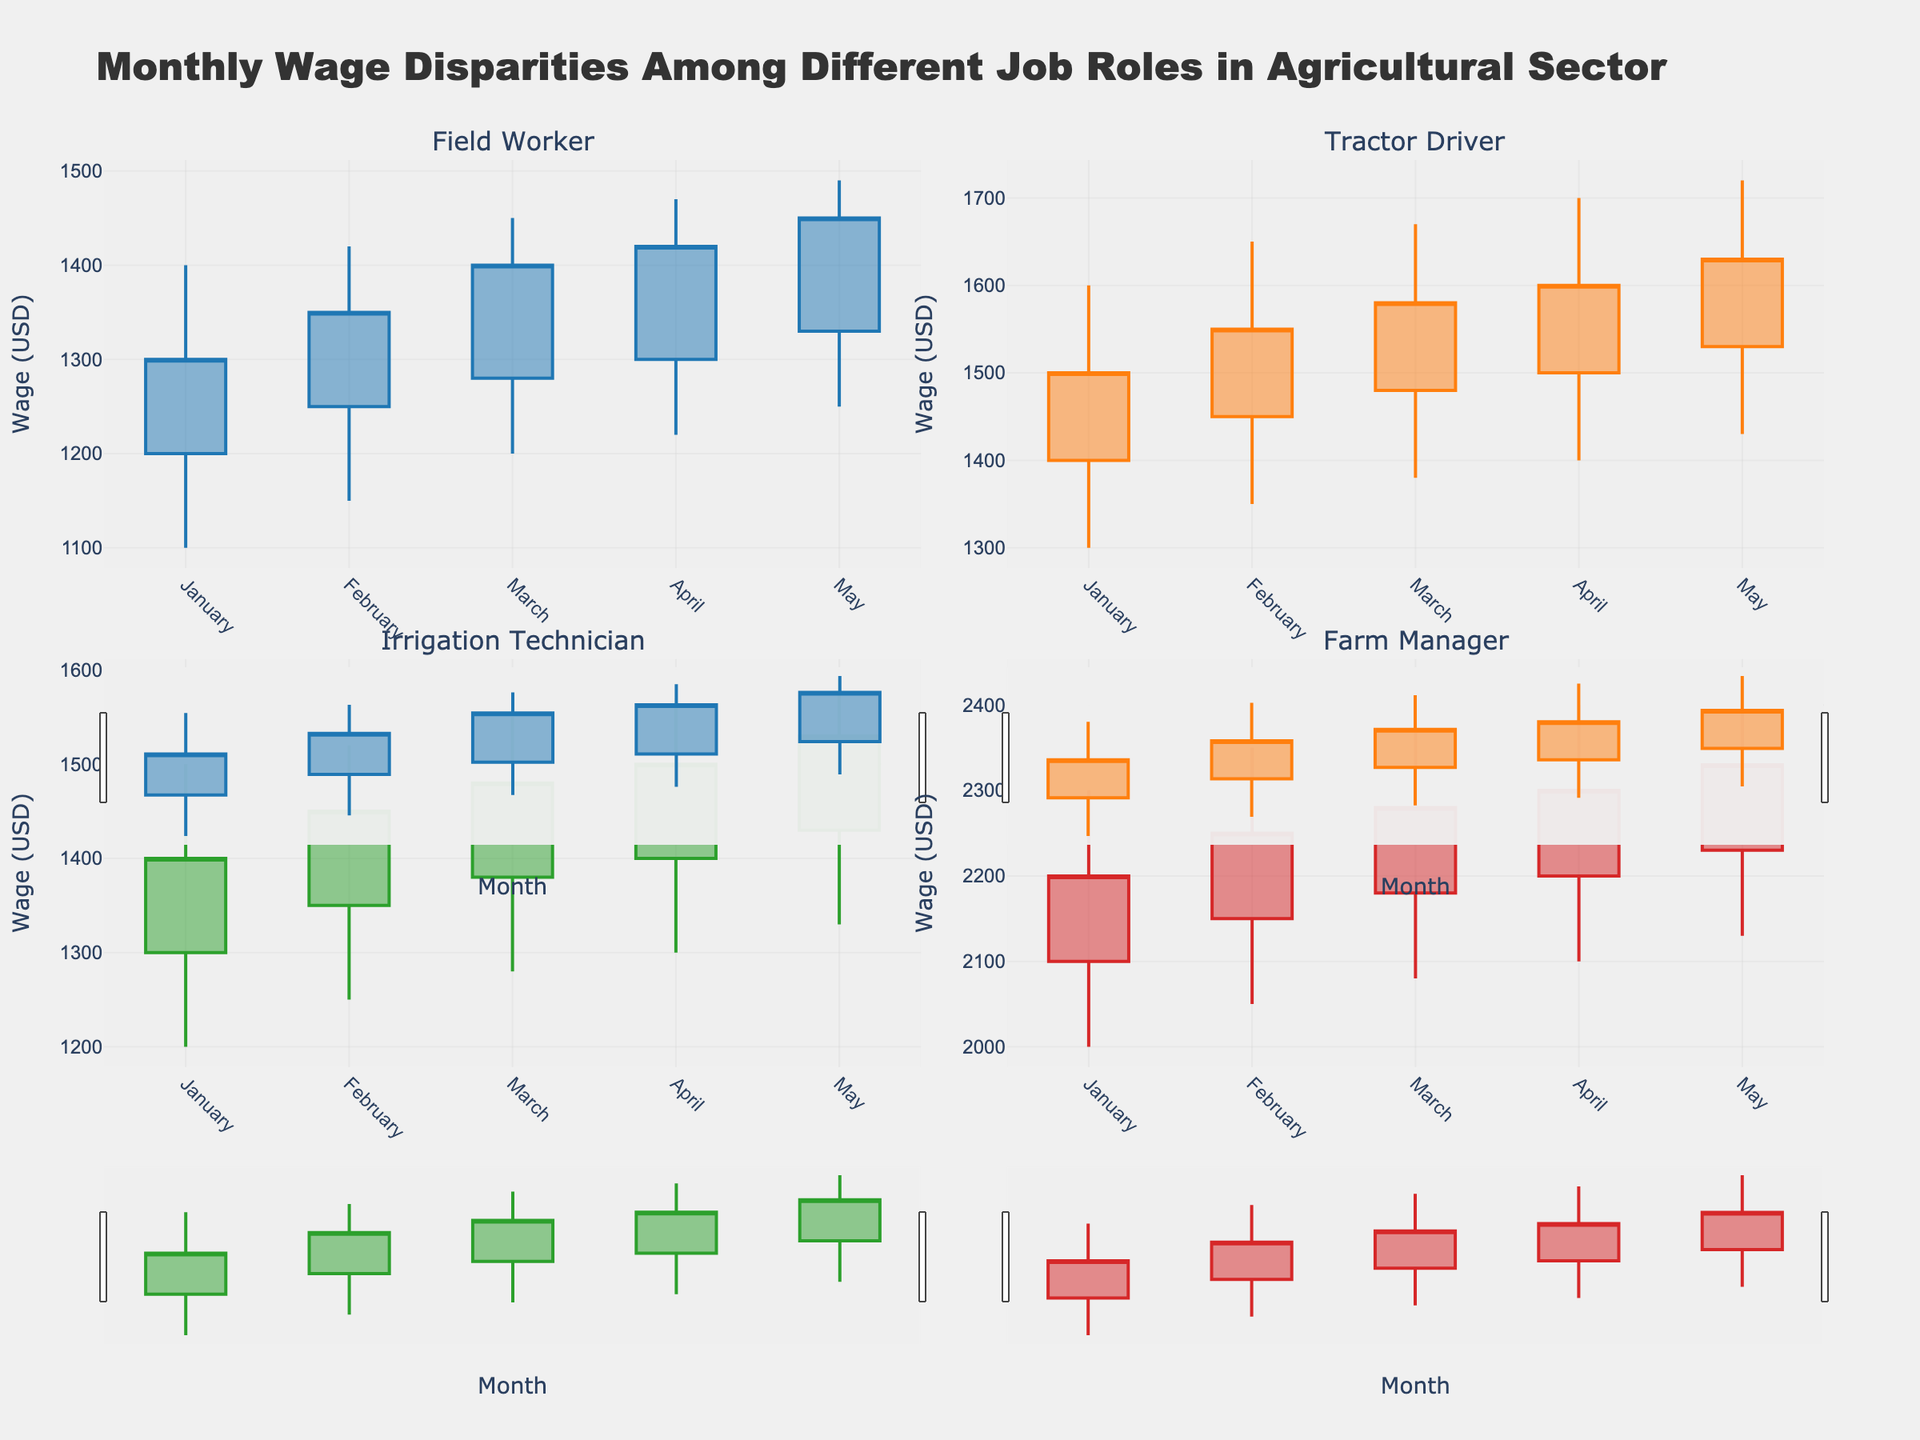What job role has the highest average wage in May? Look at the candlestick plots for each job role in May, calculate the average wage for each by taking the mean of Open, High, Low, and Close values. Compare the averages to find the highest.
Answer: Farm Manager What is the title of the overall chart? Look at the top of the figure where the title is usually placed.
Answer: Monthly Wage Disparities Among Different Job Roles in Agricultural Sector How does the wage trend for Field Workers change from January to May? Observe the candlestick plot for Field Workers from January to May, noting the trend in close values which indicate the monthly end wages.
Answer: Increasing Which job role shows the smallest range of wages in April? Compare the High and Low values in April for each job role. The smallest difference indicates the smallest wage range.
Answer: Irrigation Technician Which job role experienced the largest wage increase from January to February? For each job role, subtract the January close value from the February close value. Identify the job role with the largest difference.
Answer: Farm Manager What is the highest wage recorded for Tractor Drivers in any month? Look at the highest points (High values) of the candlestick plots for Tractor Drivers across all months.
Answer: 1720 Compare the closing wage in March for Irrigation Technicians and Tractor Drivers. Which is higher? Identify the March close values for both Irrigation Technicians and Tractor Drivers from their respective candlestick plots; compare the values.
Answer: Tractor Drivers What can you infer about the wage stability for Farm Managers across the months? Examine the candlestick plot for Farm Managers, noting the consistency or variations in Open, High, Low, and Close values over the months.
Answer: Stable with steady increments Is there a month where all job roles have increasing wages? For each month, check if the Close value is higher than the Open value for all job roles' candlestick plots.
Answer: No 